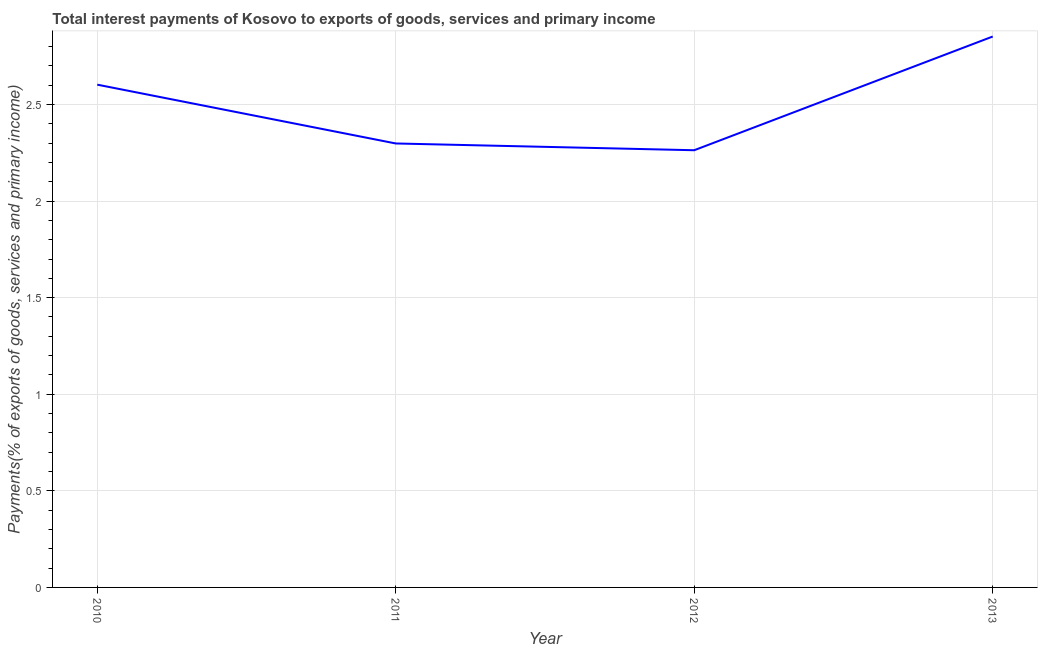What is the total interest payments on external debt in 2011?
Provide a short and direct response. 2.3. Across all years, what is the maximum total interest payments on external debt?
Your answer should be very brief. 2.85. Across all years, what is the minimum total interest payments on external debt?
Your answer should be compact. 2.26. In which year was the total interest payments on external debt maximum?
Make the answer very short. 2013. In which year was the total interest payments on external debt minimum?
Give a very brief answer. 2012. What is the sum of the total interest payments on external debt?
Provide a succinct answer. 10.02. What is the difference between the total interest payments on external debt in 2010 and 2011?
Make the answer very short. 0.3. What is the average total interest payments on external debt per year?
Ensure brevity in your answer.  2.5. What is the median total interest payments on external debt?
Offer a terse response. 2.45. In how many years, is the total interest payments on external debt greater than 1.6 %?
Give a very brief answer. 4. Do a majority of the years between 2010 and 2011 (inclusive) have total interest payments on external debt greater than 2.1 %?
Make the answer very short. Yes. What is the ratio of the total interest payments on external debt in 2012 to that in 2013?
Make the answer very short. 0.79. Is the total interest payments on external debt in 2010 less than that in 2011?
Your response must be concise. No. What is the difference between the highest and the second highest total interest payments on external debt?
Give a very brief answer. 0.25. What is the difference between the highest and the lowest total interest payments on external debt?
Provide a short and direct response. 0.59. In how many years, is the total interest payments on external debt greater than the average total interest payments on external debt taken over all years?
Your response must be concise. 2. Does the total interest payments on external debt monotonically increase over the years?
Your answer should be compact. No. How many years are there in the graph?
Provide a succinct answer. 4. What is the difference between two consecutive major ticks on the Y-axis?
Make the answer very short. 0.5. What is the title of the graph?
Your response must be concise. Total interest payments of Kosovo to exports of goods, services and primary income. What is the label or title of the Y-axis?
Give a very brief answer. Payments(% of exports of goods, services and primary income). What is the Payments(% of exports of goods, services and primary income) of 2010?
Give a very brief answer. 2.6. What is the Payments(% of exports of goods, services and primary income) in 2011?
Keep it short and to the point. 2.3. What is the Payments(% of exports of goods, services and primary income) in 2012?
Offer a terse response. 2.26. What is the Payments(% of exports of goods, services and primary income) in 2013?
Offer a terse response. 2.85. What is the difference between the Payments(% of exports of goods, services and primary income) in 2010 and 2011?
Offer a very short reply. 0.3. What is the difference between the Payments(% of exports of goods, services and primary income) in 2010 and 2012?
Provide a succinct answer. 0.34. What is the difference between the Payments(% of exports of goods, services and primary income) in 2010 and 2013?
Ensure brevity in your answer.  -0.25. What is the difference between the Payments(% of exports of goods, services and primary income) in 2011 and 2012?
Your answer should be very brief. 0.03. What is the difference between the Payments(% of exports of goods, services and primary income) in 2011 and 2013?
Make the answer very short. -0.55. What is the difference between the Payments(% of exports of goods, services and primary income) in 2012 and 2013?
Keep it short and to the point. -0.59. What is the ratio of the Payments(% of exports of goods, services and primary income) in 2010 to that in 2011?
Ensure brevity in your answer.  1.13. What is the ratio of the Payments(% of exports of goods, services and primary income) in 2010 to that in 2012?
Offer a terse response. 1.15. What is the ratio of the Payments(% of exports of goods, services and primary income) in 2011 to that in 2012?
Your answer should be very brief. 1.01. What is the ratio of the Payments(% of exports of goods, services and primary income) in 2011 to that in 2013?
Make the answer very short. 0.81. What is the ratio of the Payments(% of exports of goods, services and primary income) in 2012 to that in 2013?
Your answer should be very brief. 0.79. 